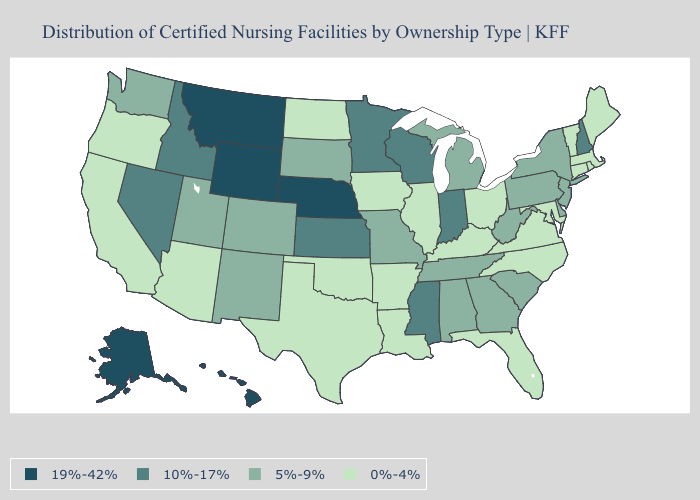What is the value of North Dakota?
Be succinct. 0%-4%. What is the lowest value in the South?
Keep it brief. 0%-4%. Does Hawaii have the highest value in the USA?
Concise answer only. Yes. Name the states that have a value in the range 5%-9%?
Answer briefly. Alabama, Colorado, Delaware, Georgia, Michigan, Missouri, New Jersey, New Mexico, New York, Pennsylvania, South Carolina, South Dakota, Tennessee, Utah, Washington, West Virginia. What is the lowest value in the USA?
Concise answer only. 0%-4%. What is the value of New Hampshire?
Write a very short answer. 10%-17%. Does North Dakota have a higher value than Michigan?
Answer briefly. No. What is the lowest value in the USA?
Quick response, please. 0%-4%. Among the states that border Nebraska , does Colorado have the lowest value?
Quick response, please. No. What is the value of Virginia?
Concise answer only. 0%-4%. Name the states that have a value in the range 0%-4%?
Quick response, please. Arizona, Arkansas, California, Connecticut, Florida, Illinois, Iowa, Kentucky, Louisiana, Maine, Maryland, Massachusetts, North Carolina, North Dakota, Ohio, Oklahoma, Oregon, Rhode Island, Texas, Vermont, Virginia. What is the value of New Jersey?
Keep it brief. 5%-9%. What is the value of South Carolina?
Short answer required. 5%-9%. What is the value of Alaska?
Write a very short answer. 19%-42%. 